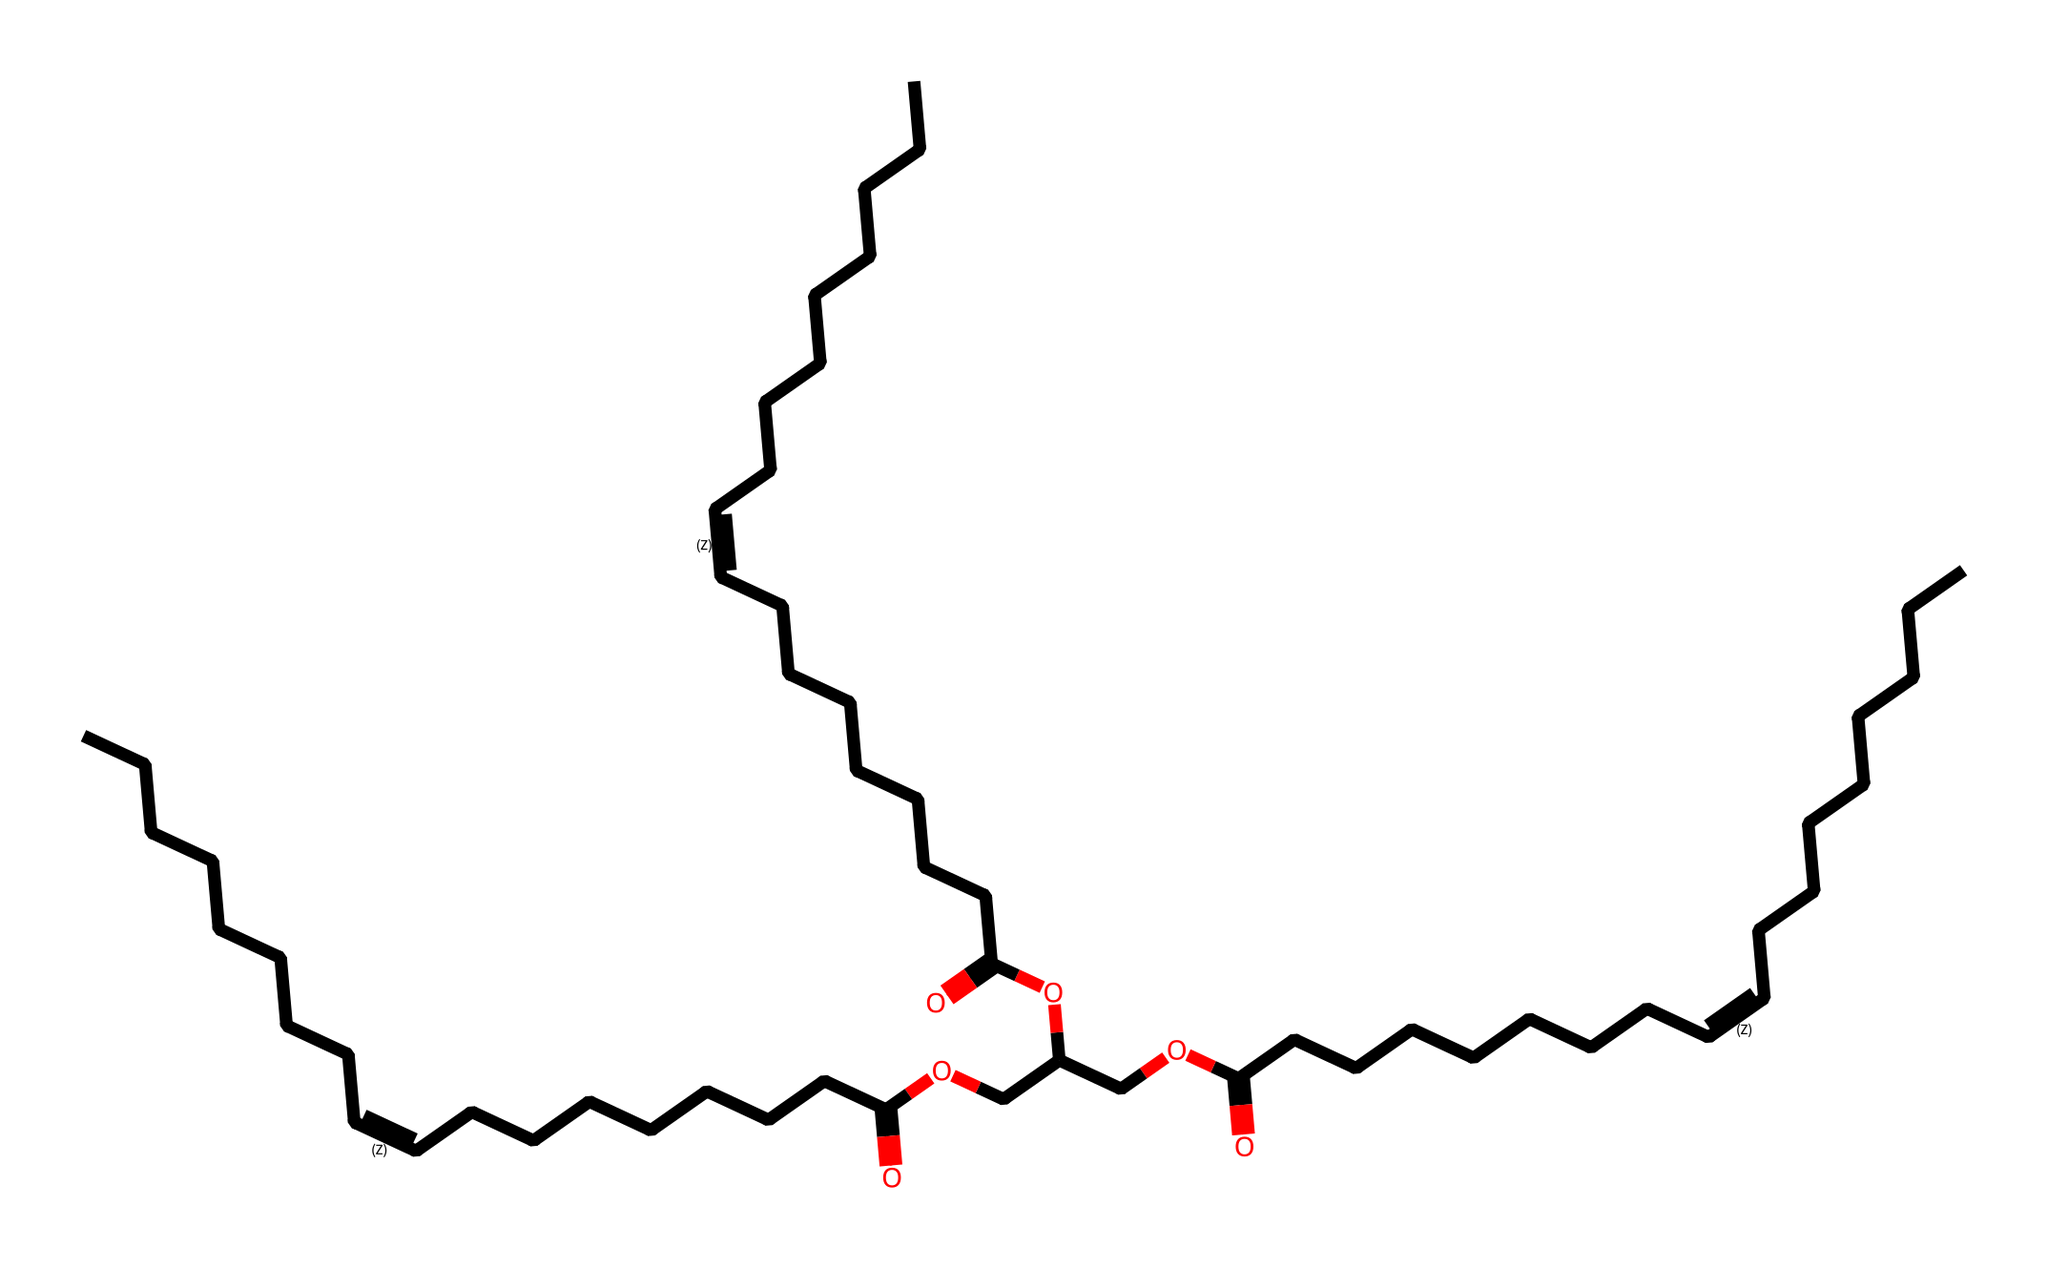How many carbon atoms are present in this chemical structure? By examining the SMILES representation, we can count the number of 'C' symbols. In this case, there are 36 carbon atoms total, as every carbon atom is represented by a 'C'.
Answer: 36 What is the functional group present in this chemical? The structure contains a carboxylic acid group, which is indicated by the presence of '-COOH' in the representation. This is confirmed by the appearance of 'C(=O)O' in the SMILES.
Answer: carboxylic acid What type of fatty acids does this chemical likely contain? The presence of the '/C=C\' notation suggests that the structure contains unsaturated fatty acids due to the double bonds between carbon atoms. Thus, it likely contains unsaturated fatty acids.
Answer: unsaturated fatty acids How many double bonds are present in the chemical structure? The '/C=C\' notation indicates the presence of a double bond. By examining the SMILES, there are three instances of '/C=C\' indicating three double bonds in total.
Answer: 3 What type of substance is this chemical, given its structure? This chemical is recognized as a lubricant due to the presence of long-chain fatty acids, which are characteristic of plant-based oils used in Ayurvedic practice, contributing to its lubricating properties.
Answer: lubricant Which trait of this chemical contributes to its ability to moisturize skin? The long hydrocarbon chains and the carboxylic acid functional group both contribute to the emollient and moisturizing properties of the substance, allowing it to soften and soothe skin.
Answer: emollient 